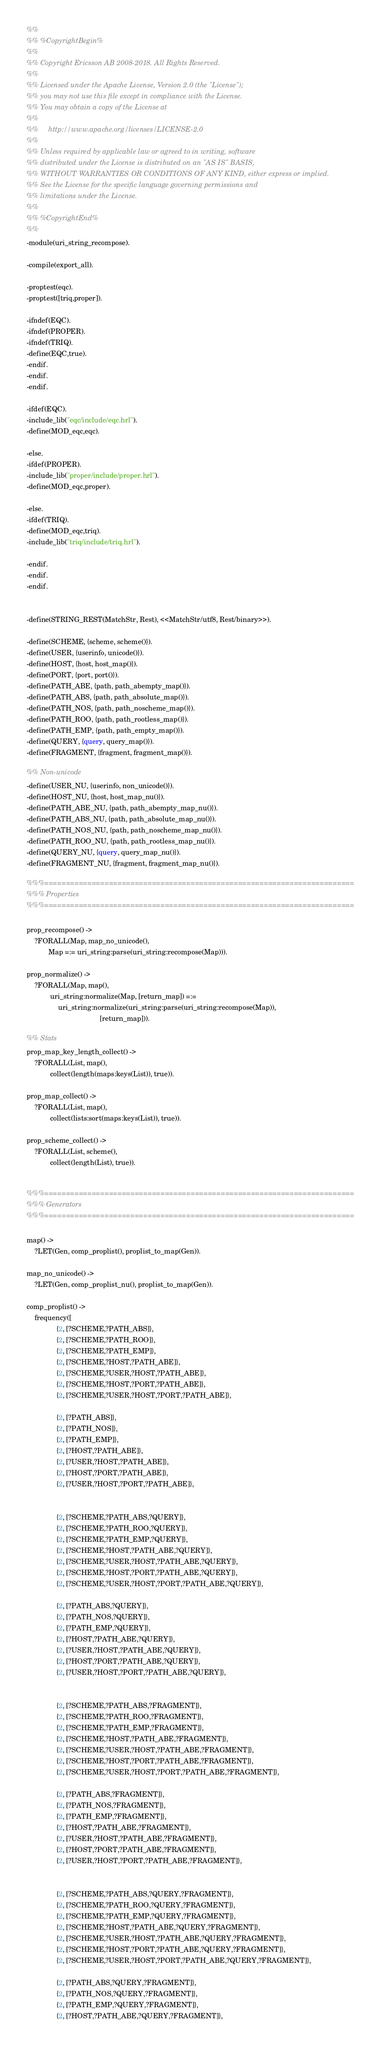Convert code to text. <code><loc_0><loc_0><loc_500><loc_500><_Erlang_>%%
%% %CopyrightBegin%
%%
%% Copyright Ericsson AB 2008-2018. All Rights Reserved.
%%
%% Licensed under the Apache License, Version 2.0 (the "License");
%% you may not use this file except in compliance with the License.
%% You may obtain a copy of the License at
%%
%%     http://www.apache.org/licenses/LICENSE-2.0
%%
%% Unless required by applicable law or agreed to in writing, software
%% distributed under the License is distributed on an "AS IS" BASIS,
%% WITHOUT WARRANTIES OR CONDITIONS OF ANY KIND, either express or implied.
%% See the License for the specific language governing permissions and
%% limitations under the License.
%%
%% %CopyrightEnd%
%%
-module(uri_string_recompose).

-compile(export_all).

-proptest(eqc).
-proptest([triq,proper]).

-ifndef(EQC).
-ifndef(PROPER).
-ifndef(TRIQ).
-define(EQC,true).
-endif.
-endif.
-endif.

-ifdef(EQC).
-include_lib("eqc/include/eqc.hrl").
-define(MOD_eqc,eqc).

-else.
-ifdef(PROPER).
-include_lib("proper/include/proper.hrl").
-define(MOD_eqc,proper).

-else.
-ifdef(TRIQ).
-define(MOD_eqc,triq).
-include_lib("triq/include/triq.hrl").

-endif.
-endif.
-endif.


-define(STRING_REST(MatchStr, Rest), <<MatchStr/utf8, Rest/binary>>).

-define(SCHEME, {scheme, scheme()}).
-define(USER, {userinfo, unicode()}).
-define(HOST, {host, host_map()}).
-define(PORT, {port, port()}).
-define(PATH_ABE, {path, path_abempty_map()}).
-define(PATH_ABS, {path, path_absolute_map()}).
-define(PATH_NOS, {path, path_noscheme_map()}).
-define(PATH_ROO, {path, path_rootless_map()}).
-define(PATH_EMP, {path, path_empty_map()}).
-define(QUERY, {query, query_map()}).
-define(FRAGMENT, {fragment, fragment_map()}).

%% Non-unicode
-define(USER_NU, {userinfo, non_unicode()}).
-define(HOST_NU, {host, host_map_nu()}).
-define(PATH_ABE_NU, {path, path_abempty_map_nu()}).
-define(PATH_ABS_NU, {path, path_absolute_map_nu()}).
-define(PATH_NOS_NU, {path, path_noscheme_map_nu()}).
-define(PATH_ROO_NU, {path, path_rootless_map_nu()}).
-define(QUERY_NU, {query, query_map_nu()}).
-define(FRAGMENT_NU, {fragment, fragment_map_nu()}).

%%%========================================================================
%%% Properties
%%%========================================================================

prop_recompose() ->
    ?FORALL(Map, map_no_unicode(),
           Map =:= uri_string:parse(uri_string:recompose(Map))).

prop_normalize() ->
    ?FORALL(Map, map(),
            uri_string:normalize(Map, [return_map]) =:=
                uri_string:normalize(uri_string:parse(uri_string:recompose(Map)),
                                     [return_map])).

%% Stats
prop_map_key_length_collect() ->
    ?FORALL(List, map(),
            collect(length(maps:keys(List)), true)).

prop_map_collect() ->
    ?FORALL(List, map(),
            collect(lists:sort(maps:keys(List)), true)).

prop_scheme_collect() ->
    ?FORALL(List, scheme(),
            collect(length(List), true)).


%%%========================================================================
%%% Generators
%%%========================================================================

map() ->
    ?LET(Gen, comp_proplist(), proplist_to_map(Gen)).

map_no_unicode() ->
    ?LET(Gen, comp_proplist_nu(), proplist_to_map(Gen)).

comp_proplist() ->
    frequency([
               {2, [?SCHEME,?PATH_ABS]},
               {2, [?SCHEME,?PATH_ROO]},
               {2, [?SCHEME,?PATH_EMP]},
               {2, [?SCHEME,?HOST,?PATH_ABE]},
               {2, [?SCHEME,?USER,?HOST,?PATH_ABE]},
               {2, [?SCHEME,?HOST,?PORT,?PATH_ABE]},
               {2, [?SCHEME,?USER,?HOST,?PORT,?PATH_ABE]},

               {2, [?PATH_ABS]},
               {2, [?PATH_NOS]},
               {2, [?PATH_EMP]},
               {2, [?HOST,?PATH_ABE]},
               {2, [?USER,?HOST,?PATH_ABE]},
               {2, [?HOST,?PORT,?PATH_ABE]},
               {2, [?USER,?HOST,?PORT,?PATH_ABE]},


               {2, [?SCHEME,?PATH_ABS,?QUERY]},
               {2, [?SCHEME,?PATH_ROO,?QUERY]},
               {2, [?SCHEME,?PATH_EMP,?QUERY]},
               {2, [?SCHEME,?HOST,?PATH_ABE,?QUERY]},
               {2, [?SCHEME,?USER,?HOST,?PATH_ABE,?QUERY]},
               {2, [?SCHEME,?HOST,?PORT,?PATH_ABE,?QUERY]},
               {2, [?SCHEME,?USER,?HOST,?PORT,?PATH_ABE,?QUERY]},

               {2, [?PATH_ABS,?QUERY]},
               {2, [?PATH_NOS,?QUERY]},
               {2, [?PATH_EMP,?QUERY]},
               {2, [?HOST,?PATH_ABE,?QUERY]},
               {2, [?USER,?HOST,?PATH_ABE,?QUERY]},
               {2, [?HOST,?PORT,?PATH_ABE,?QUERY]},
               {2, [?USER,?HOST,?PORT,?PATH_ABE,?QUERY]},


               {2, [?SCHEME,?PATH_ABS,?FRAGMENT]},
               {2, [?SCHEME,?PATH_ROO,?FRAGMENT]},
               {2, [?SCHEME,?PATH_EMP,?FRAGMENT]},
               {2, [?SCHEME,?HOST,?PATH_ABE,?FRAGMENT]},
               {2, [?SCHEME,?USER,?HOST,?PATH_ABE,?FRAGMENT]},
               {2, [?SCHEME,?HOST,?PORT,?PATH_ABE,?FRAGMENT]},
               {2, [?SCHEME,?USER,?HOST,?PORT,?PATH_ABE,?FRAGMENT]},

               {2, [?PATH_ABS,?FRAGMENT]},
               {2, [?PATH_NOS,?FRAGMENT]},
               {2, [?PATH_EMP,?FRAGMENT]},
               {2, [?HOST,?PATH_ABE,?FRAGMENT]},
               {2, [?USER,?HOST,?PATH_ABE,?FRAGMENT]},
               {2, [?HOST,?PORT,?PATH_ABE,?FRAGMENT]},
               {2, [?USER,?HOST,?PORT,?PATH_ABE,?FRAGMENT]},


               {2, [?SCHEME,?PATH_ABS,?QUERY,?FRAGMENT]},
               {2, [?SCHEME,?PATH_ROO,?QUERY,?FRAGMENT]},
               {2, [?SCHEME,?PATH_EMP,?QUERY,?FRAGMENT]},
               {2, [?SCHEME,?HOST,?PATH_ABE,?QUERY,?FRAGMENT]},
               {2, [?SCHEME,?USER,?HOST,?PATH_ABE,?QUERY,?FRAGMENT]},
               {2, [?SCHEME,?HOST,?PORT,?PATH_ABE,?QUERY,?FRAGMENT]},
               {2, [?SCHEME,?USER,?HOST,?PORT,?PATH_ABE,?QUERY,?FRAGMENT]},

               {2, [?PATH_ABS,?QUERY,?FRAGMENT]},
               {2, [?PATH_NOS,?QUERY,?FRAGMENT]},
               {2, [?PATH_EMP,?QUERY,?FRAGMENT]},
               {2, [?HOST,?PATH_ABE,?QUERY,?FRAGMENT]},</code> 